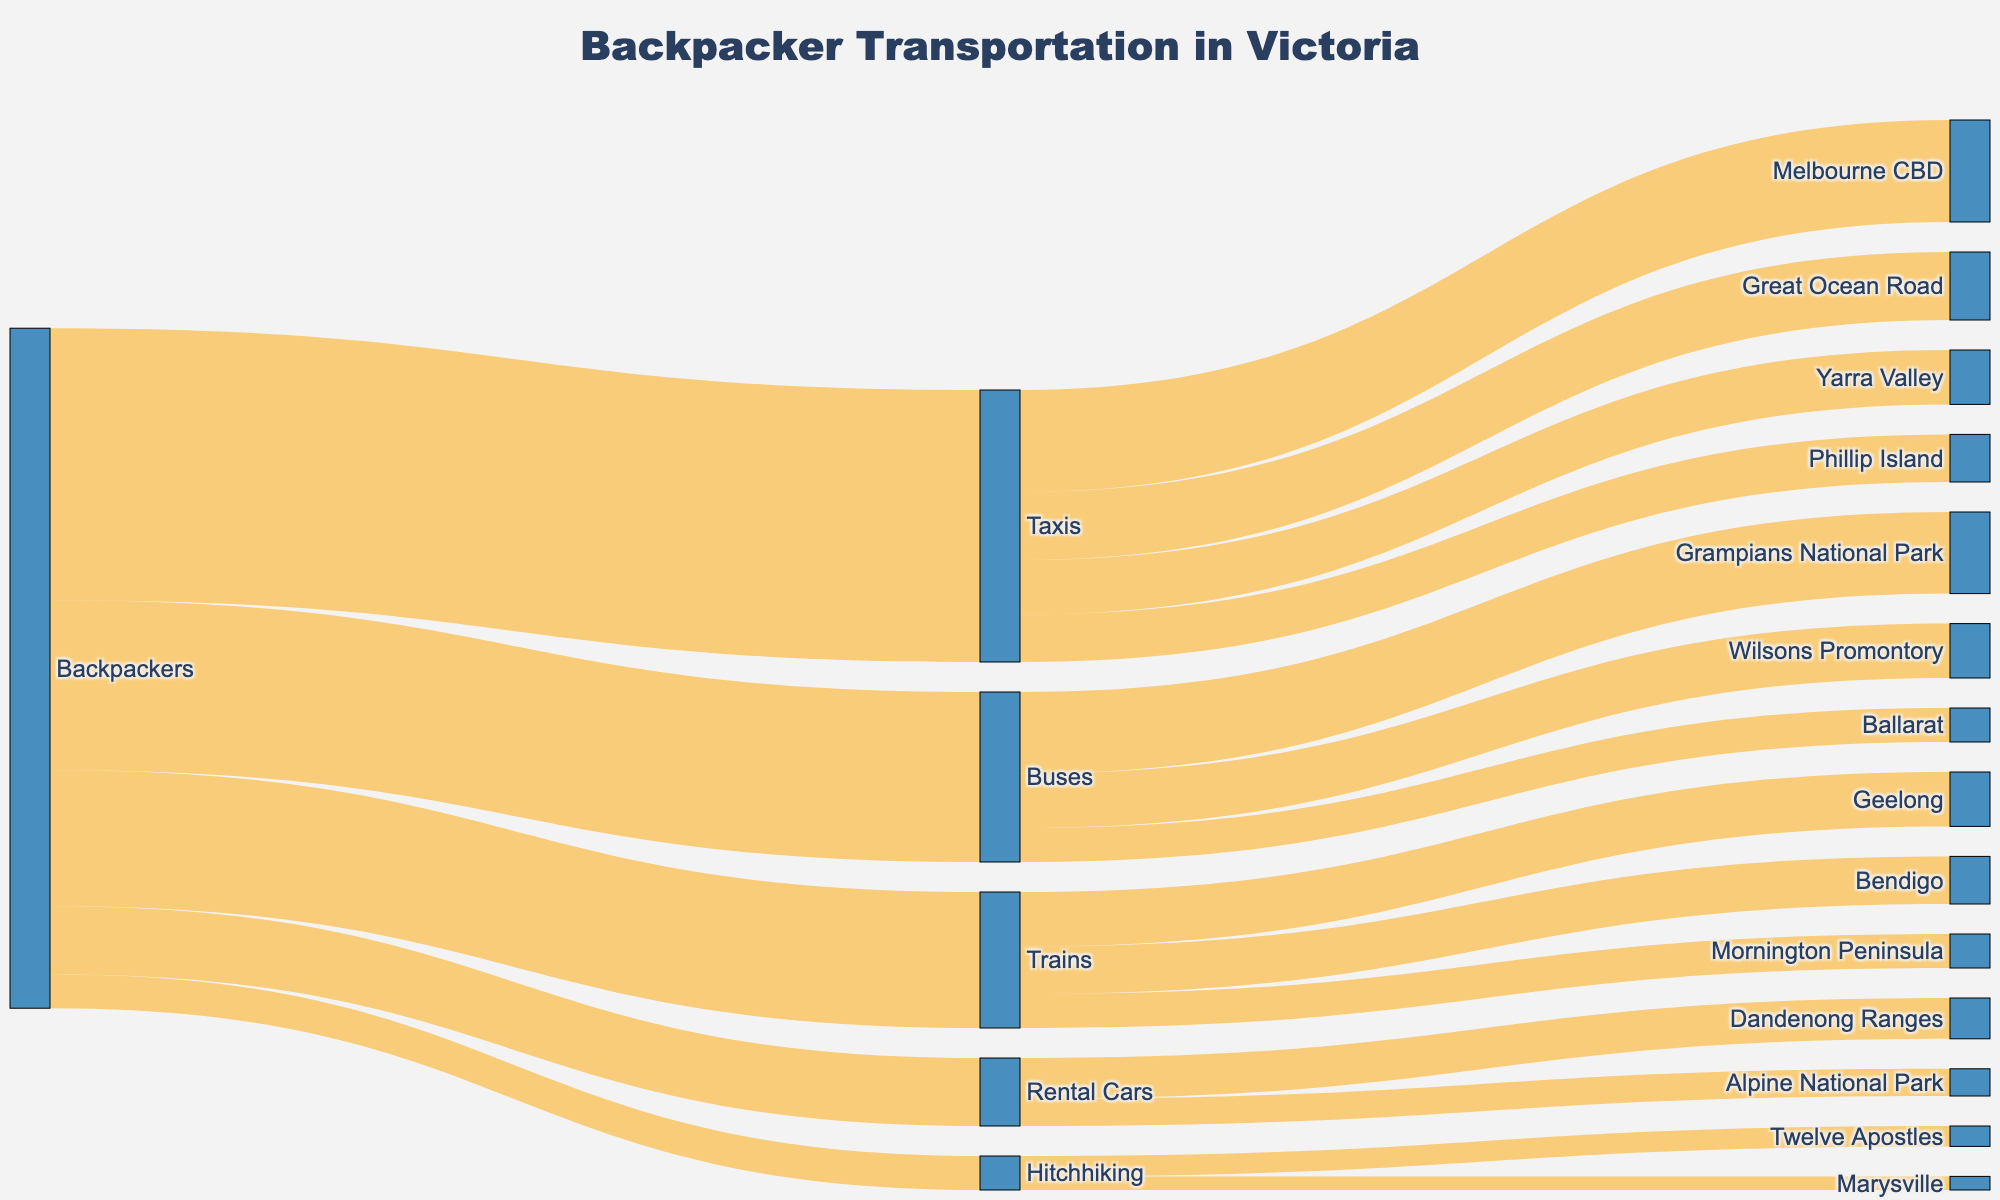What is the title of the Sankey Diagram? The title is usually displayed at the top of the figure. In this case, it should indicate the main topic of the diagram.
Answer: "Backpacker Transportation in Victoria" How many transportation modes are used by backpackers? To determine the number of transportation modes, count the unique entries directly linked to "Backpackers" in the diagram. These are Taxis, Buses, Trains, Rental Cars, and Hitchhiking.
Answer: 5 Which transportation mode is most frequently used by backpackers? Find the mode with the highest flow value directly linked to "Backpackers". Here, Taxis have the highest value at 40.
Answer: Taxis How many backpackers use buses? Look at the value from "Backpackers" to "Buses" in the diagram. It is represented by 25.
Answer: 25 What is the total number of backpackers using Taxis, Buses, and Trains combined? Add the values from "Backpackers" to Taxis, Buses, and Trains: 40 (Taxis) + 25 (Buses) + 20 (Trains).
Answer: 85 Which destination receives the least number of backpackers traveling by trains? Among the destinations linked to "Trains", compare the values. Mornington Peninsula has the lowest value at 5.
Answer: Mornington Peninsula What are the top two destinations for backpackers using taxis? From the destinations linked to "Taxis", identify those with the highest values. Melbourne CBD (15) and Great Ocean Road (10) are the top two.
Answer: Melbourne CBD and Great Ocean Road Is the number of backpackers using rental cars greater than those hitchhiking? Compare the values directly linked from "Backpackers" to Rental Cars (10) and Hitchhiking (5).
Answer: Yes What percentage of backpackers use Taxis? Calculate the percentage using the formula: (Number of backpackers using Taxis / Total number of backpackers) * 100. The total number is the sum of all values from "Backpackers": 100. So, (40/100)*100.
Answer: 40% Calculate the total number of backpackers using each transportation mode and visiting each destination. Sum the values for each category. This involves adding the values for each connection under each transportation mode and ensuring all source groups are included in the total count calculation.
Answer: Total = 100 (Backpackers) 